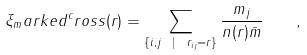<formula> <loc_0><loc_0><loc_500><loc_500>\xi _ { m } a r k e d ^ { c } r o s s ( r ) = \sum _ { \{ i , j \ | \ r _ { i j } = r \} } \frac { m _ { j } } { n ( r ) \bar { m } } \quad ,</formula> 